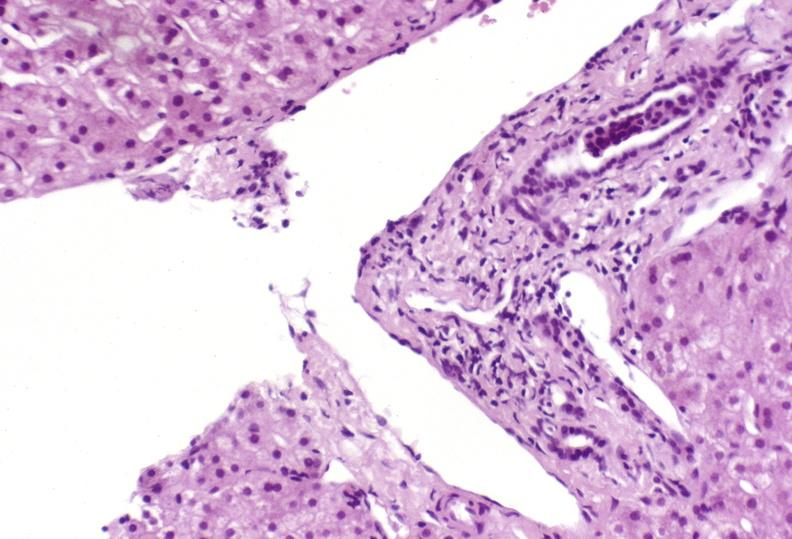s capillary present?
Answer the question using a single word or phrase. No 